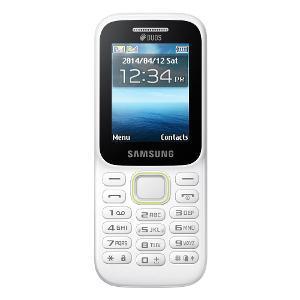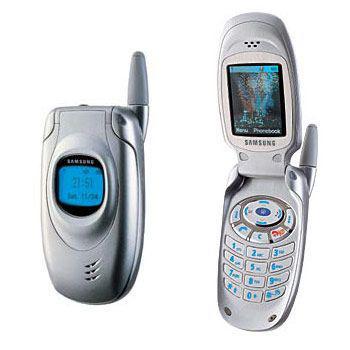The first image is the image on the left, the second image is the image on the right. Examine the images to the left and right. Is the description "There are more phones in the image on the right." accurate? Answer yes or no. Yes. The first image is the image on the left, the second image is the image on the right. Considering the images on both sides, is "The right image shows an opened flip phone." valid? Answer yes or no. Yes. 